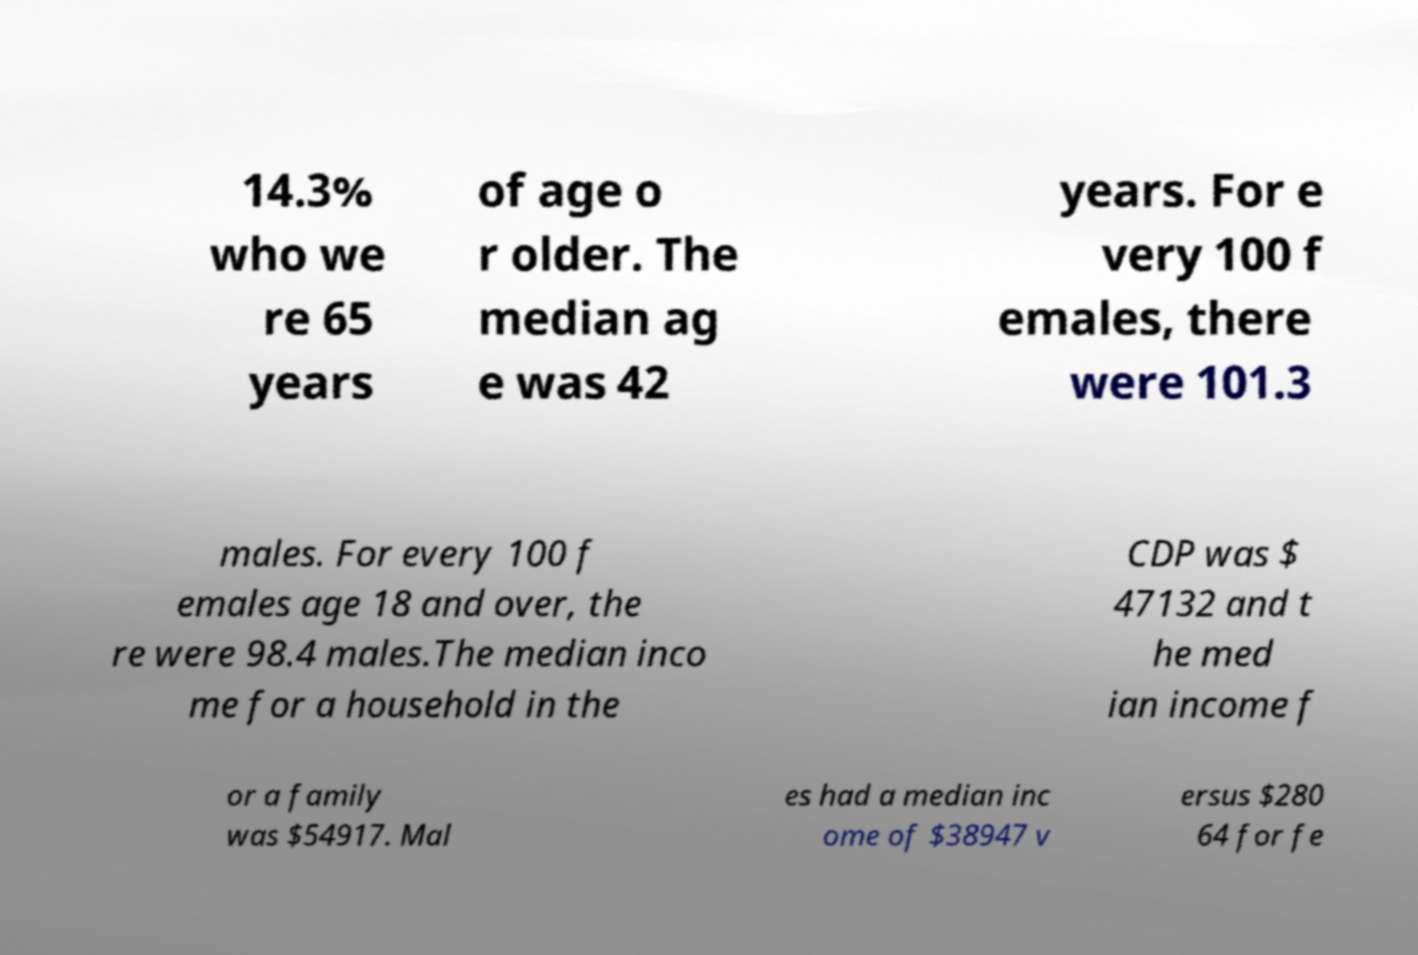Can you read and provide the text displayed in the image?This photo seems to have some interesting text. Can you extract and type it out for me? 14.3% who we re 65 years of age o r older. The median ag e was 42 years. For e very 100 f emales, there were 101.3 males. For every 100 f emales age 18 and over, the re were 98.4 males.The median inco me for a household in the CDP was $ 47132 and t he med ian income f or a family was $54917. Mal es had a median inc ome of $38947 v ersus $280 64 for fe 